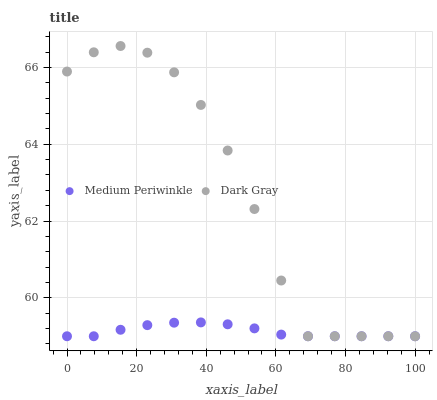Does Medium Periwinkle have the minimum area under the curve?
Answer yes or no. Yes. Does Dark Gray have the maximum area under the curve?
Answer yes or no. Yes. Does Medium Periwinkle have the maximum area under the curve?
Answer yes or no. No. Is Medium Periwinkle the smoothest?
Answer yes or no. Yes. Is Dark Gray the roughest?
Answer yes or no. Yes. Is Medium Periwinkle the roughest?
Answer yes or no. No. Does Dark Gray have the lowest value?
Answer yes or no. Yes. Does Dark Gray have the highest value?
Answer yes or no. Yes. Does Medium Periwinkle have the highest value?
Answer yes or no. No. Does Medium Periwinkle intersect Dark Gray?
Answer yes or no. Yes. Is Medium Periwinkle less than Dark Gray?
Answer yes or no. No. Is Medium Periwinkle greater than Dark Gray?
Answer yes or no. No. 